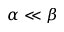Convert formula to latex. <formula><loc_0><loc_0><loc_500><loc_500>\alpha \ll \beta</formula> 